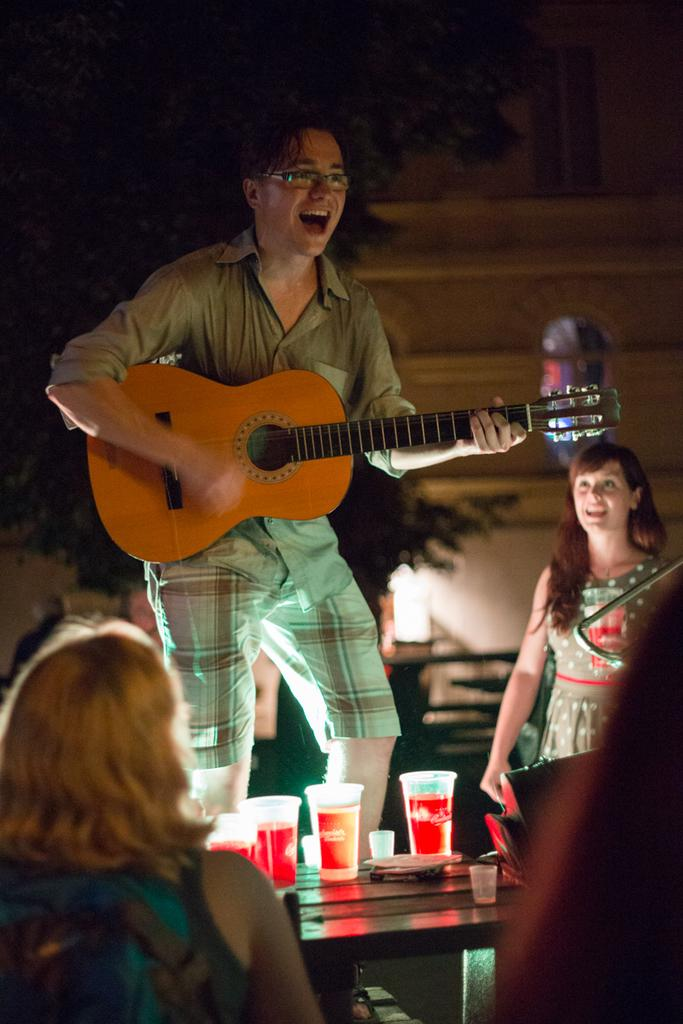What is happening in the image? There are people in the image, and one person is playing the guitar. What is the person playing the guitar doing? The person playing the guitar is shouting. Who else is present in the image? There are two girls watching the person playing the guitar. What can be observed about the background of the image? The background of the image is dark. Can you see a hose being used by the person playing the guitar in the image? There is no hose present in the image, and the person playing the guitar is not using one. 